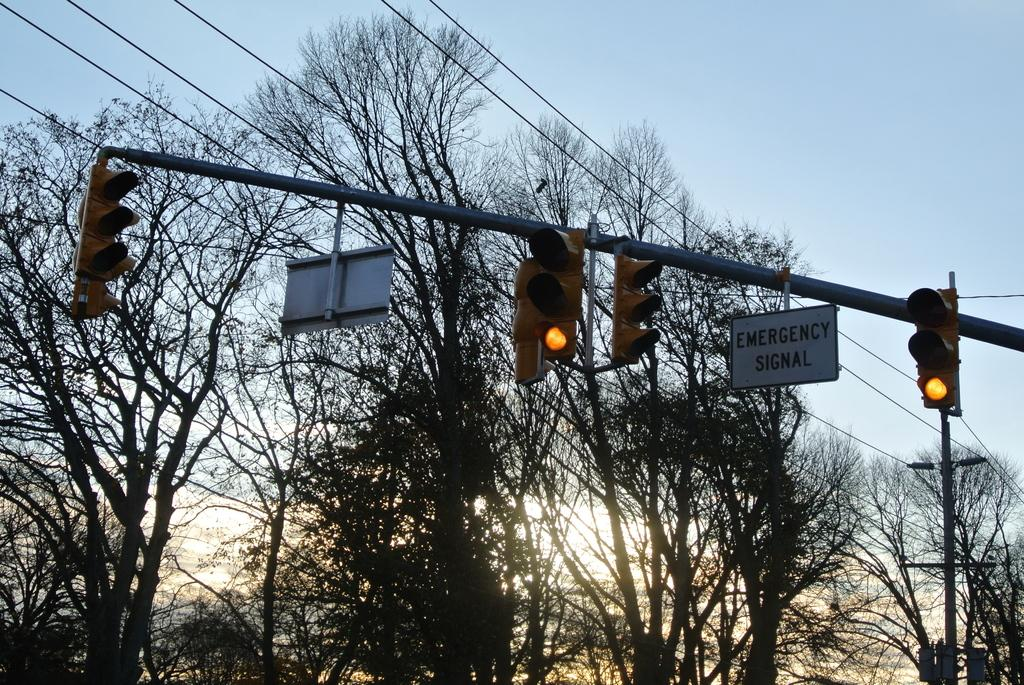What is located in the center of the image? There are signal lights and cable wires in the center of the image. What can be seen in the background of the image? There are trees and a current pole in the background of the image. What is the condition of the sky in the image? The sky is clear in the image. What time of day is depicted in the image? It is sunset time in the image. Can you see any apples on the current pole in the image? There are no apples present in the image, and the current pole does not have any apples on it. How many snails are crawling on the signal lights in the image? There are no snails visible on the signal lights in the image. 